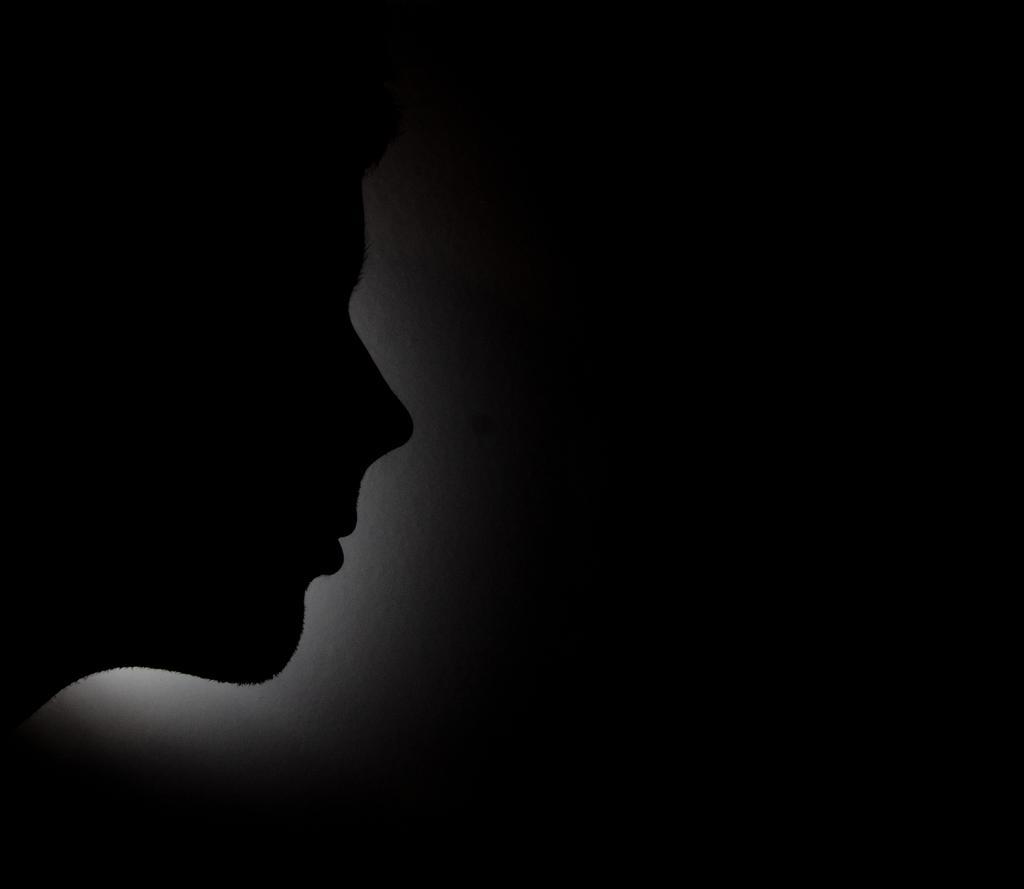Can you describe this image briefly? In this picture I can observe a person. There is a white color light behind the person. The background is completely dark. 